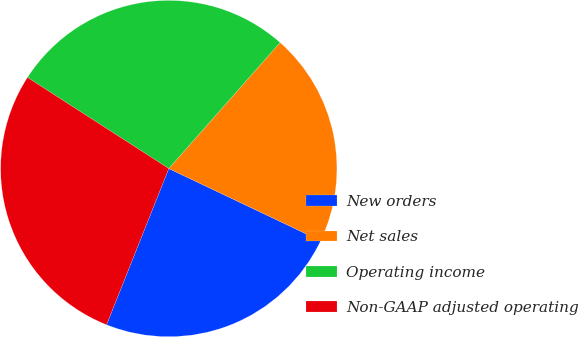Convert chart. <chart><loc_0><loc_0><loc_500><loc_500><pie_chart><fcel>New orders<fcel>Net sales<fcel>Operating income<fcel>Non-GAAP adjusted operating<nl><fcel>23.97%<fcel>20.55%<fcel>27.4%<fcel>28.08%<nl></chart> 